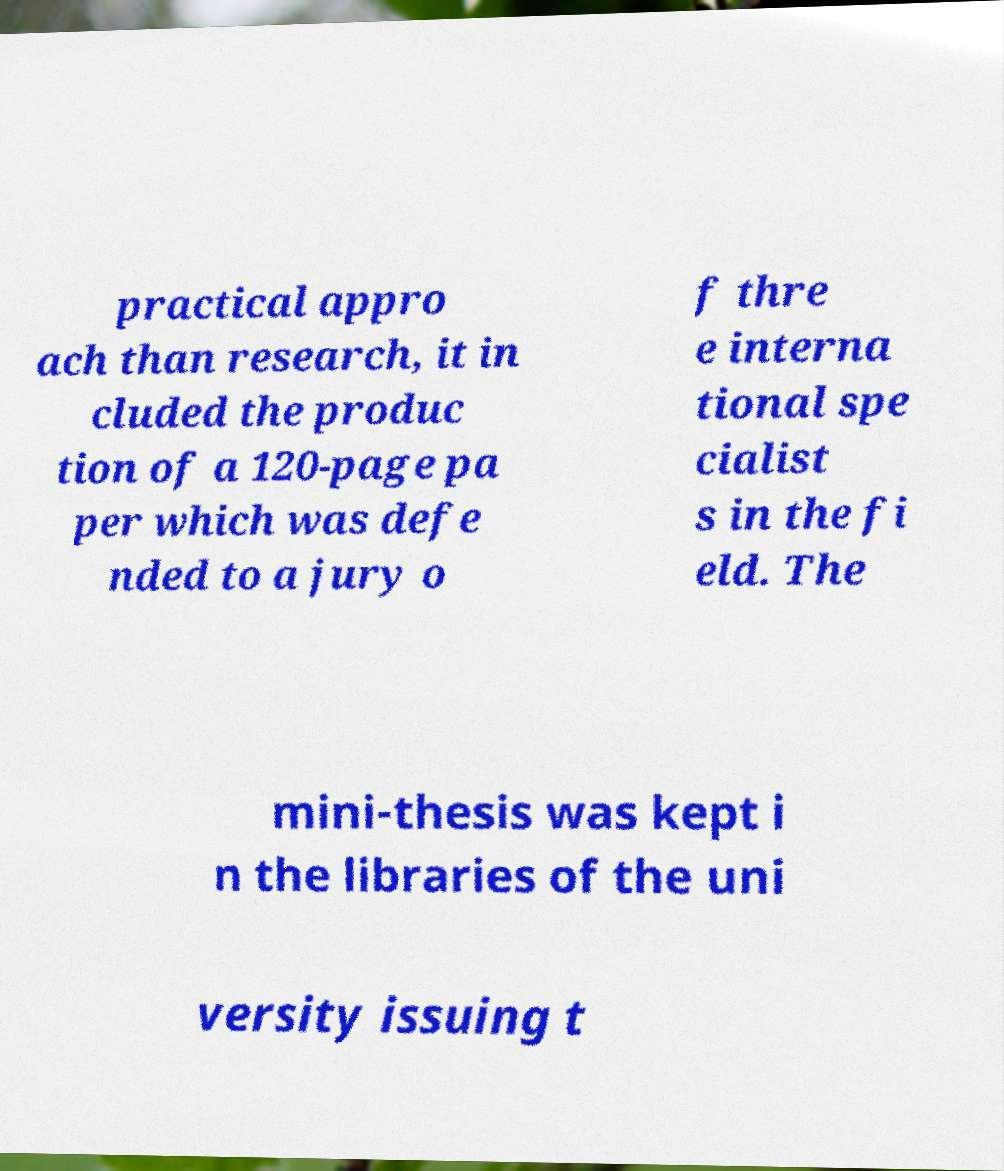For documentation purposes, I need the text within this image transcribed. Could you provide that? practical appro ach than research, it in cluded the produc tion of a 120-page pa per which was defe nded to a jury o f thre e interna tional spe cialist s in the fi eld. The mini-thesis was kept i n the libraries of the uni versity issuing t 